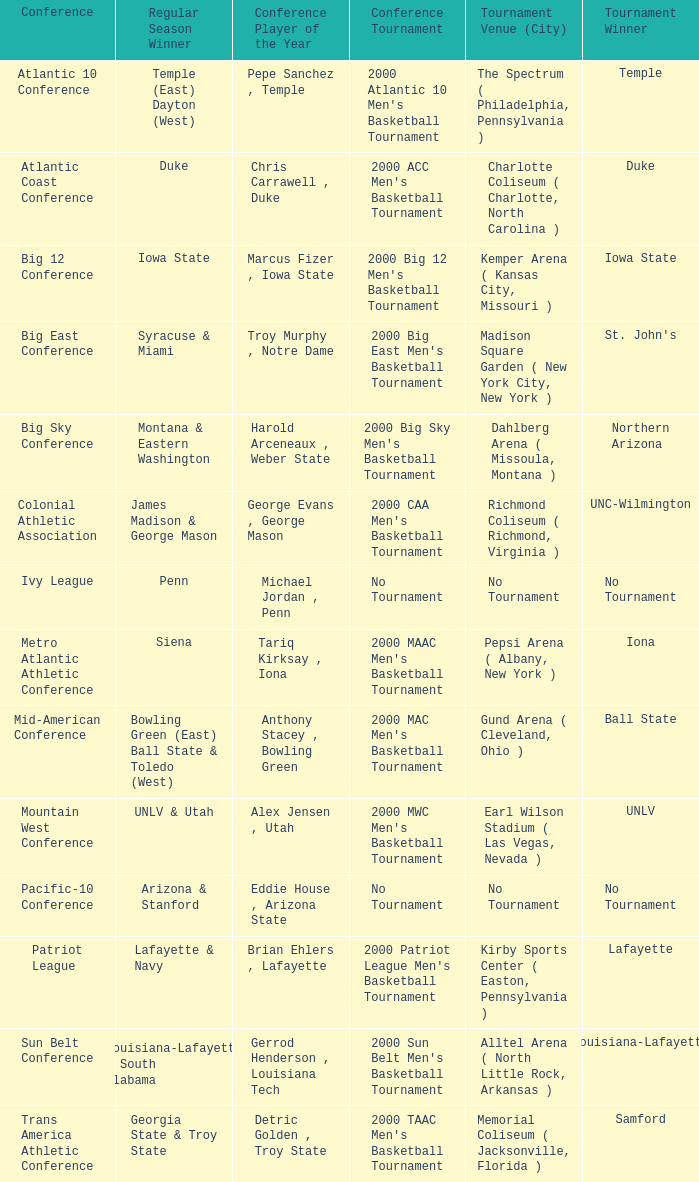What is the number of players of the year in the mountain west conference? 1.0. 